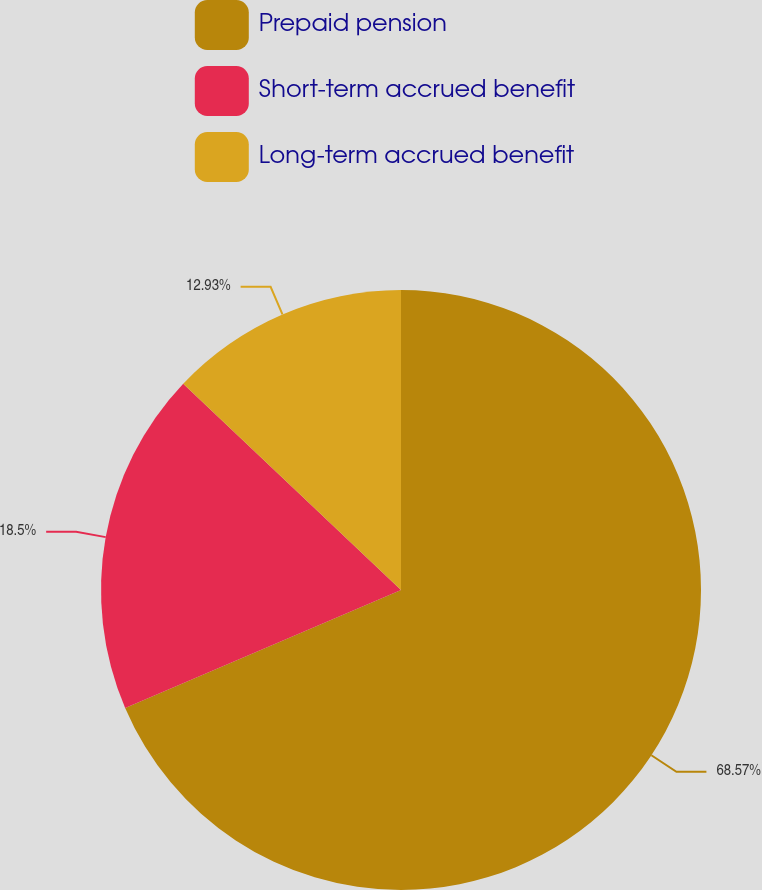Convert chart. <chart><loc_0><loc_0><loc_500><loc_500><pie_chart><fcel>Prepaid pension<fcel>Short-term accrued benefit<fcel>Long-term accrued benefit<nl><fcel>68.57%<fcel>18.5%<fcel>12.93%<nl></chart> 